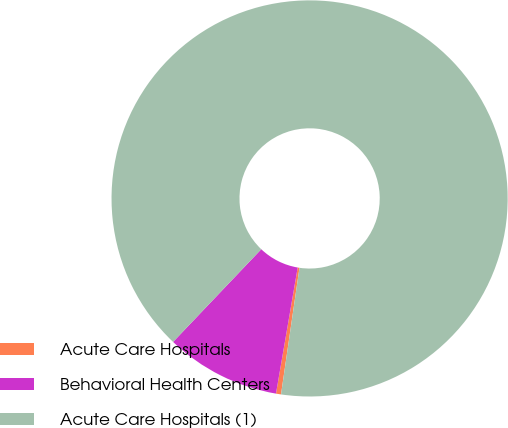Convert chart. <chart><loc_0><loc_0><loc_500><loc_500><pie_chart><fcel>Acute Care Hospitals<fcel>Behavioral Health Centers<fcel>Acute Care Hospitals (1)<nl><fcel>0.41%<fcel>9.39%<fcel>90.2%<nl></chart> 